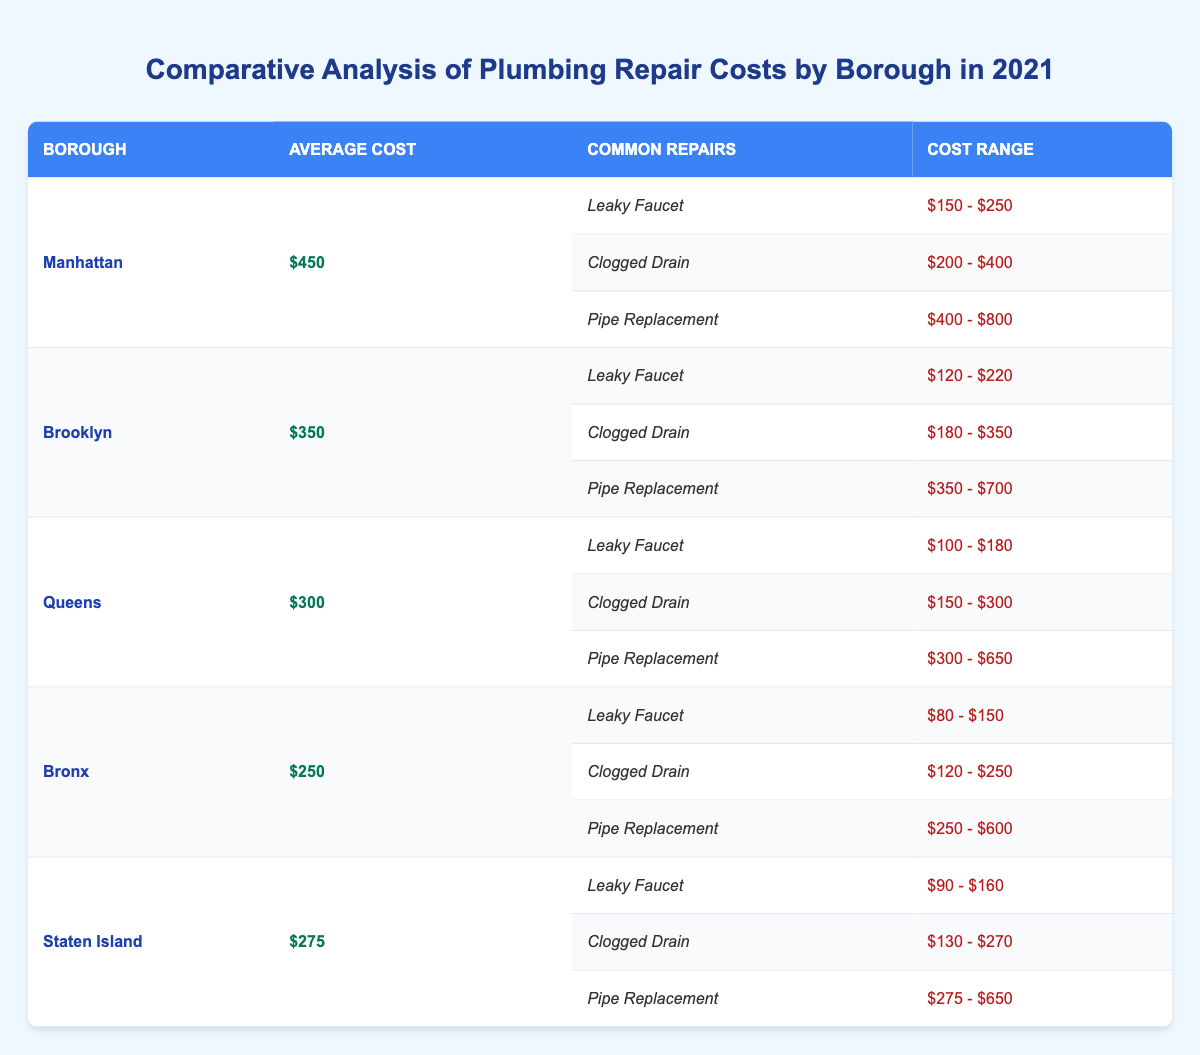What is the average plumbing repair cost in Manhattan? The table shows that the average cost for plumbing repairs in Manhattan is listed as $450.
Answer: $450 Which borough has the highest average plumbing repair cost? By comparing the average costs of all boroughs listed in the table, Manhattan has the highest average cost at $450.
Answer: Manhattan What is the cost range for a clogged drain repair in Brooklyn? In the table, the cost range for a clogged drain repair under Brooklyn is specified as $180 to $350.
Answer: $180 - $350 Is the average plumbing repair cost in the Bronx less than $300? Looking at the table, the average cost in the Bronx is $250, which is indeed less than $300.
Answer: Yes How much more expensive is a pipe replacement in Manhattan compared to Queens? From the table, a pipe replacement costs $400 to $800 in Manhattan and $300 to $650 in Queens. The minimum difference is $100 ($400 - $300) and the maximum difference is $150 ($800 - $650).
Answer: $100 - $150 What is the total average plumbing repair cost of all boroughs combined? To find the total average plumbing repair cost, we first sum the average costs: $450 + $350 + $300 + $250 + $275 = $1625. Then, divide by the number of boroughs, which is 5: $1625 / 5 = $325.
Answer: $325 Which borough has the lowest cost range for a leaky faucet repair? The cost range for a leaky faucet repair in the Bronx is $80 to $150, which is the lowest when compared with other boroughs.
Answer: Bronx Is pipe replacement generally cheaper in Queens than in Staten Island? The table shows that the cost range for pipe replacement in Queens is $300 to $650, while in Staten Island it is $275 to $650. Since the ranges overlap, the lowest possible cost in Staten Island is actually less than the lowest in Queens.
Answer: Yes Which borough offers the widest cost range for the pipe replacement repair? By assessing the stated cost ranges for pipe replacements, Manhattan ranges from $400 to $800, providing a difference of $400. This is wider than the others, with the next widest being Brooklyn at $350 to $700.
Answer: Manhattan 